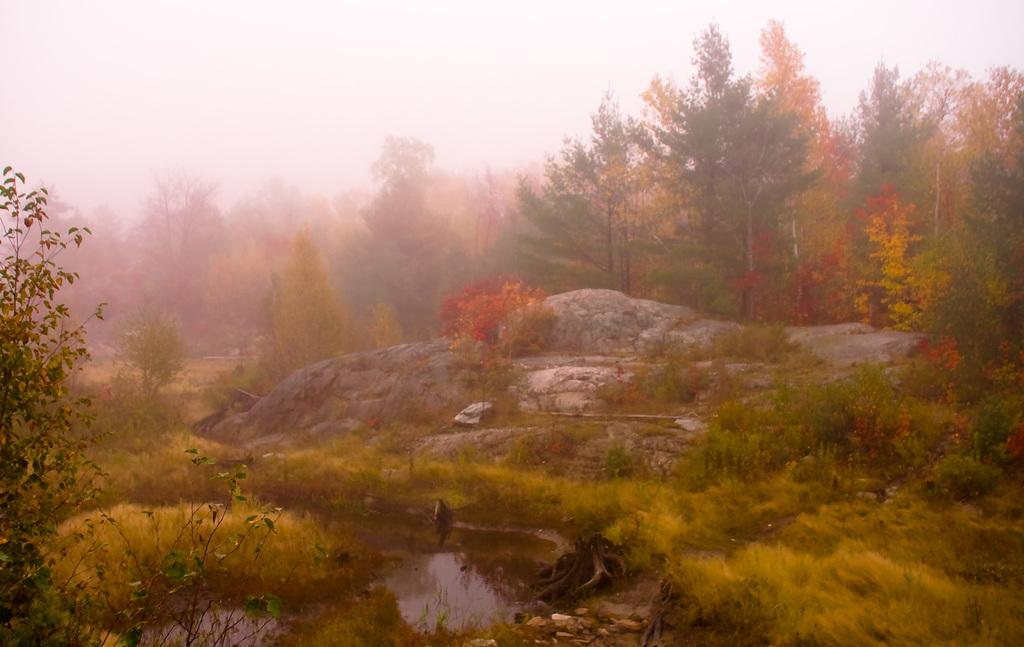What type of vegetation can be seen in the image? There is grass and plants visible in the image. What other natural elements can be seen in the image? There are rocks and water visible in the image. What is visible in the background of the image? There are trees and a clear sky visible in the background of the image. What type of holiday is being celebrated in the image? There is no indication of a holiday being celebrated in the image. Can you see a nose in the image? There is no nose present in the image. 